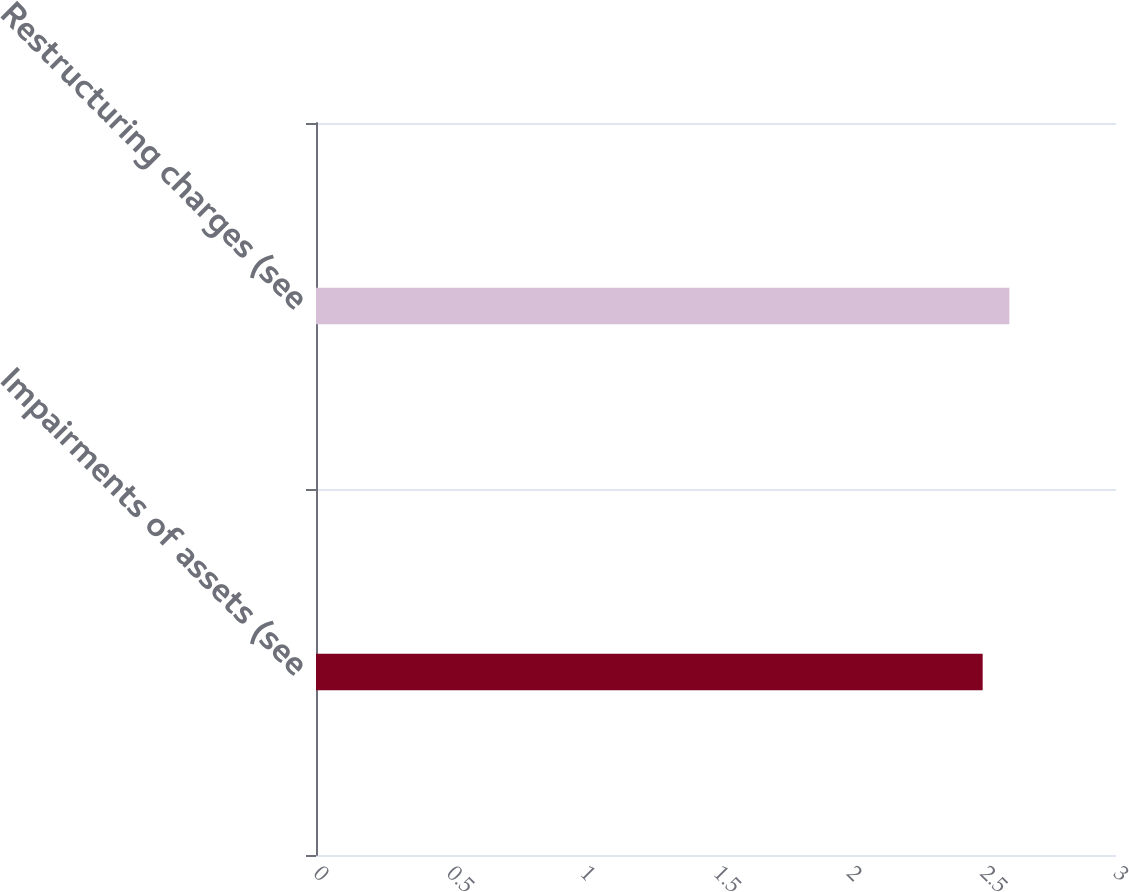Convert chart. <chart><loc_0><loc_0><loc_500><loc_500><bar_chart><fcel>Impairments of assets (see<fcel>Restructuring charges (see<nl><fcel>2.5<fcel>2.6<nl></chart> 